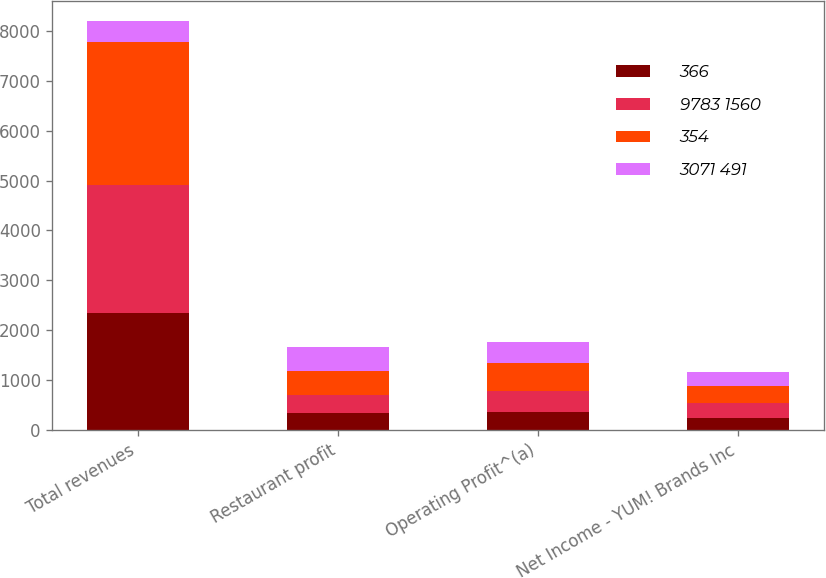Convert chart. <chart><loc_0><loc_0><loc_500><loc_500><stacked_bar_chart><ecel><fcel>Total revenues<fcel>Restaurant profit<fcel>Operating Profit^(a)<fcel>Net Income - YUM! Brands Inc<nl><fcel>366<fcel>2345<fcel>340<fcel>364<fcel>241<nl><fcel>9783 1560<fcel>2574<fcel>366<fcel>421<fcel>286<nl><fcel>354<fcel>2862<fcel>479<fcel>544<fcel>357<nl><fcel>3071 491<fcel>421<fcel>478<fcel>440<fcel>274<nl></chart> 